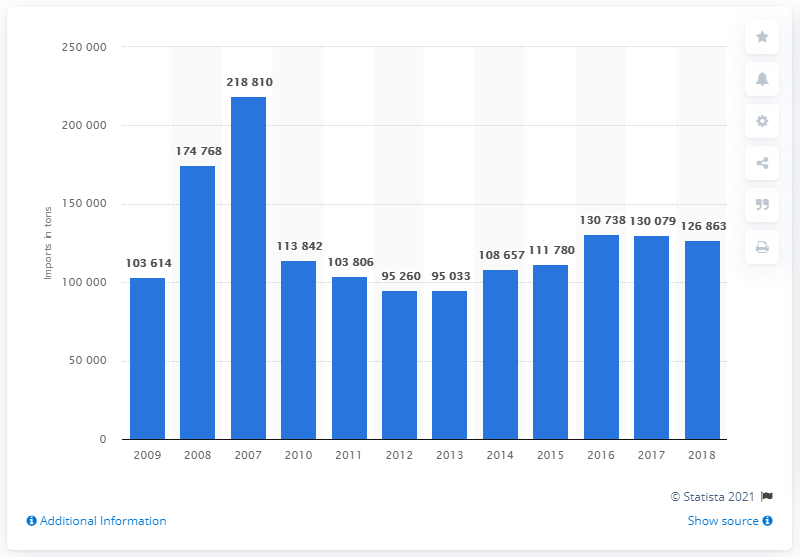Give some essential details in this illustration. In 2018, a total of 126,863 metric tons of candles were imported to the European Union. 